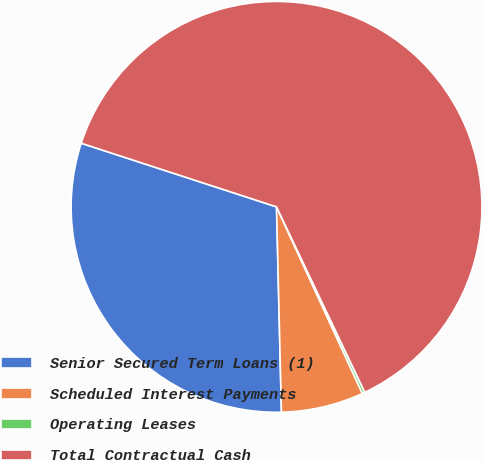Convert chart to OTSL. <chart><loc_0><loc_0><loc_500><loc_500><pie_chart><fcel>Senior Secured Term Loans (1)<fcel>Scheduled Interest Payments<fcel>Operating Leases<fcel>Total Contractual Cash<nl><fcel>30.39%<fcel>6.48%<fcel>0.21%<fcel>62.91%<nl></chart> 